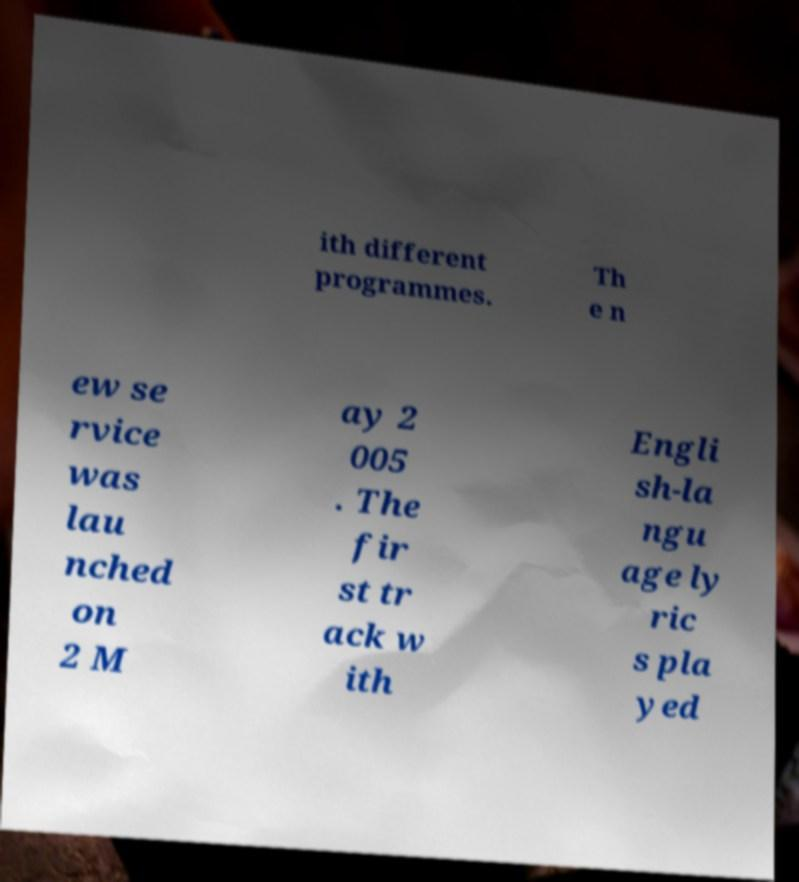Please read and relay the text visible in this image. What does it say? ith different programmes. Th e n ew se rvice was lau nched on 2 M ay 2 005 . The fir st tr ack w ith Engli sh-la ngu age ly ric s pla yed 